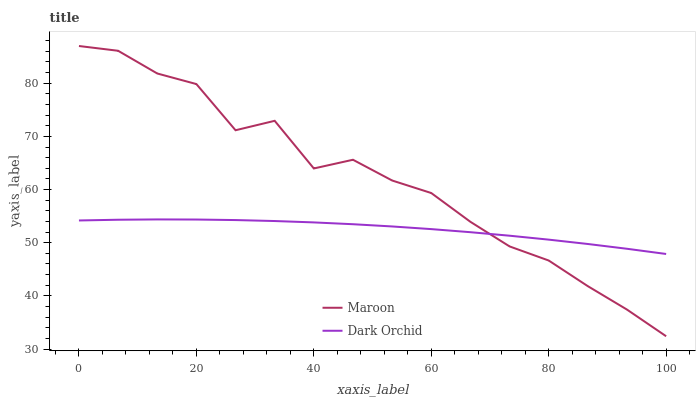Does Maroon have the minimum area under the curve?
Answer yes or no. No. Is Maroon the smoothest?
Answer yes or no. No. 